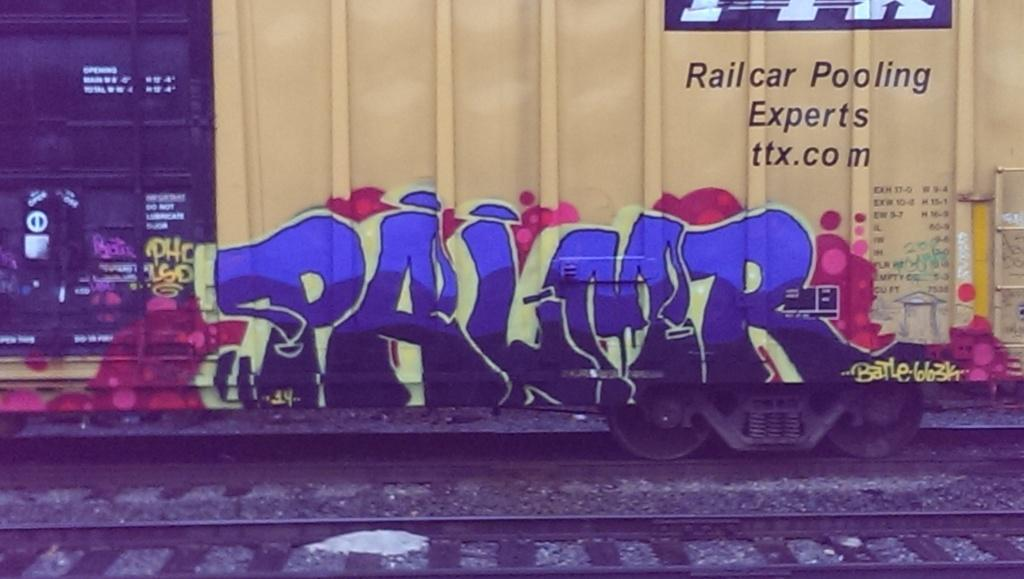<image>
Give a short and clear explanation of the subsequent image. The website for Railcar Pooling Experts is ttx.com. 